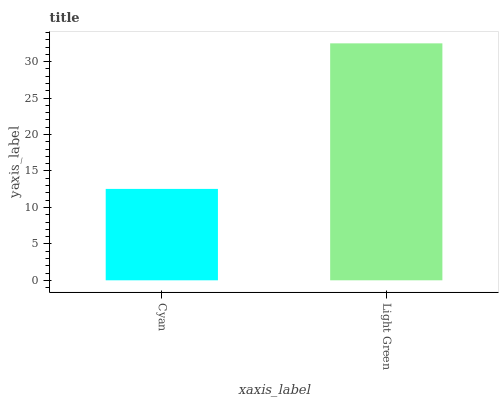Is Cyan the minimum?
Answer yes or no. Yes. Is Light Green the maximum?
Answer yes or no. Yes. Is Light Green the minimum?
Answer yes or no. No. Is Light Green greater than Cyan?
Answer yes or no. Yes. Is Cyan less than Light Green?
Answer yes or no. Yes. Is Cyan greater than Light Green?
Answer yes or no. No. Is Light Green less than Cyan?
Answer yes or no. No. Is Light Green the high median?
Answer yes or no. Yes. Is Cyan the low median?
Answer yes or no. Yes. Is Cyan the high median?
Answer yes or no. No. Is Light Green the low median?
Answer yes or no. No. 